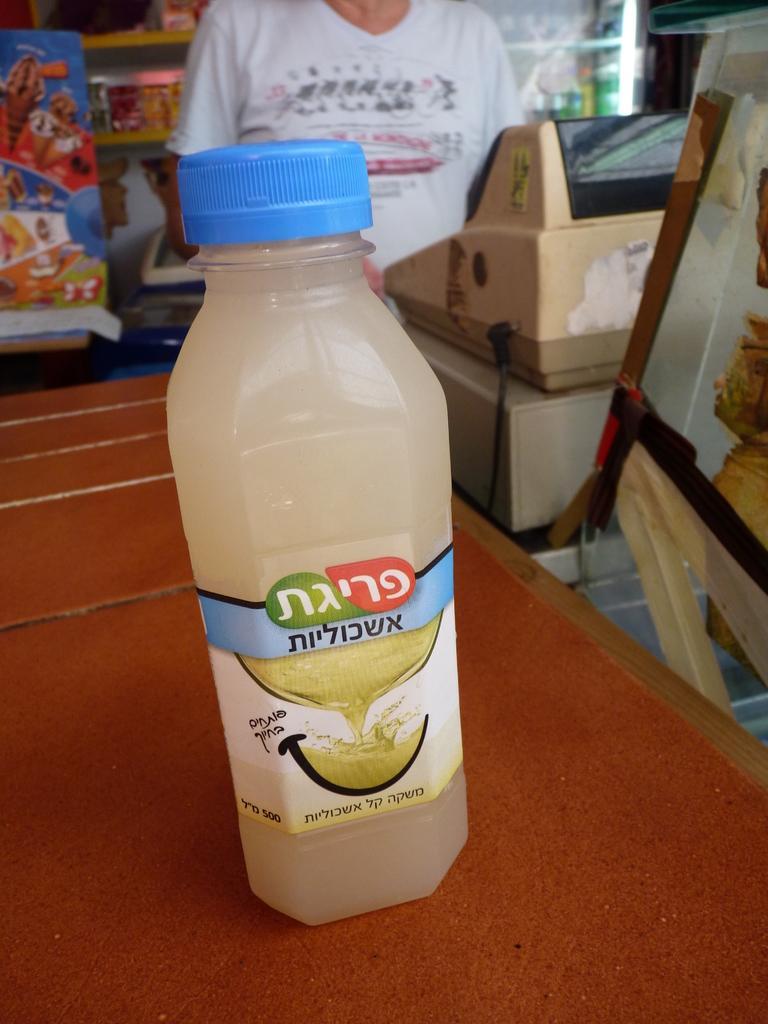Could you give a brief overview of what you see in this image? In this image I can see one person. In front there is a table. On the table there is a bottle with a blue cap. I can see a sticker to the bottle. At the back side there is a machine and some objects. The table is in orange color. 